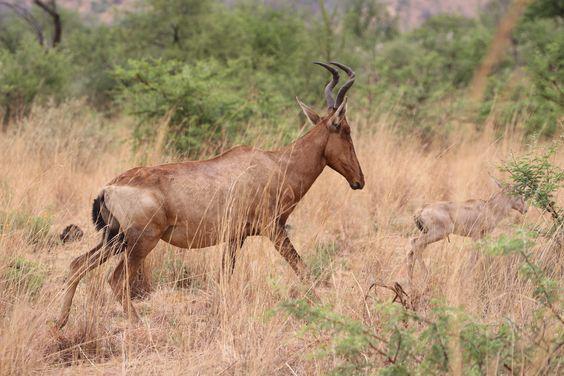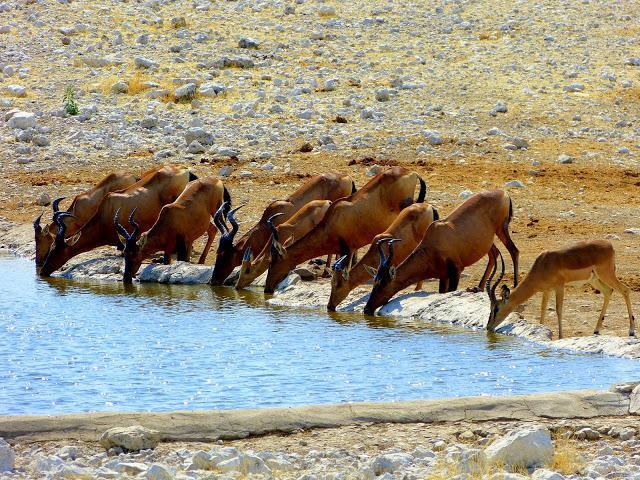The first image is the image on the left, the second image is the image on the right. Analyze the images presented: Is the assertion "In at least one image there is a single elk walking right." valid? Answer yes or no. No. The first image is the image on the left, the second image is the image on the right. For the images shown, is this caption "One image includes a single adult horned animal, and the other image features a row of horned animals who face the same direction." true? Answer yes or no. Yes. 